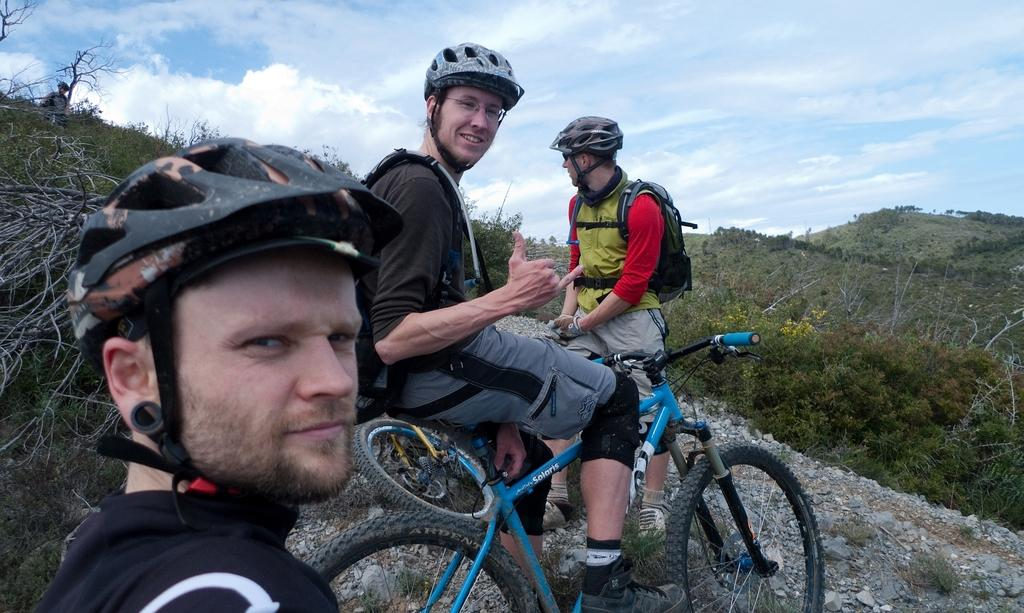How many people are in the image? There are three persons in the image. What are the persons doing in the image? The persons are sitting on a bicycle. What can be seen in the background of the image? There are mountains, trees, flowers, and the sky visible in the background of the image. What type of support can be seen being offered by the persons in the image? There is no indication in the image that the persons are offering support to anyone or anything. What kind of advice can be seen being given by the persons in the image? There is no indication in the image that the persons are giving advice to anyone or anything. 